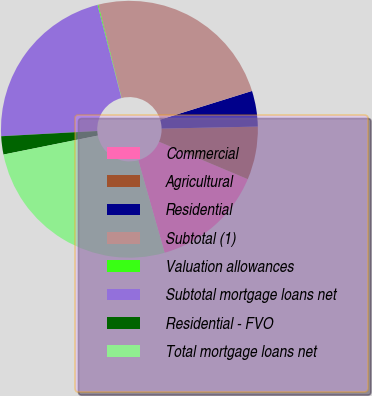<chart> <loc_0><loc_0><loc_500><loc_500><pie_chart><fcel>Commercial<fcel>Agricultural<fcel>Residential<fcel>Subtotal (1)<fcel>Valuation allowances<fcel>Subtotal mortgage loans net<fcel>Residential - FVO<fcel>Total mortgage loans net<nl><fcel>14.23%<fcel>6.68%<fcel>4.49%<fcel>24.07%<fcel>0.1%<fcel>21.87%<fcel>2.29%<fcel>26.26%<nl></chart> 